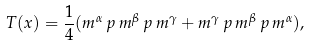Convert formula to latex. <formula><loc_0><loc_0><loc_500><loc_500>T ( x ) = \frac { 1 } { 4 } ( m ^ { \alpha } \, p \, m ^ { \beta } \, p \, m ^ { \gamma } + m ^ { \gamma } \, p \, m ^ { \beta } \, p \, m ^ { \alpha } ) ,</formula> 